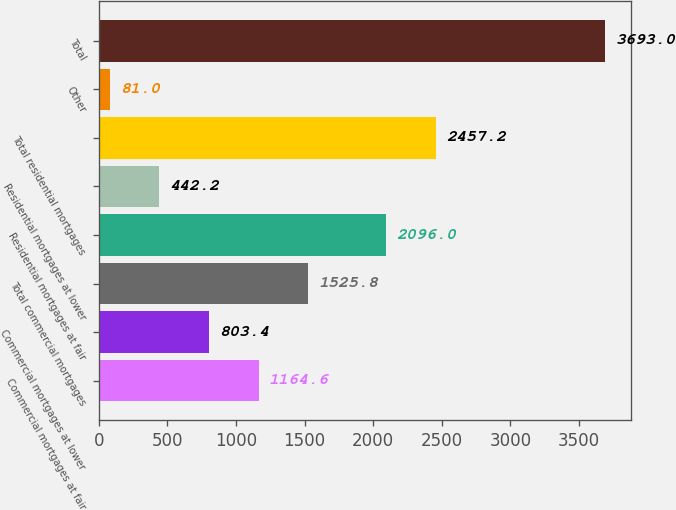Convert chart. <chart><loc_0><loc_0><loc_500><loc_500><bar_chart><fcel>Commercial mortgages at fair<fcel>Commercial mortgages at lower<fcel>Total commercial mortgages<fcel>Residential mortgages at fair<fcel>Residential mortgages at lower<fcel>Total residential mortgages<fcel>Other<fcel>Total<nl><fcel>1164.6<fcel>803.4<fcel>1525.8<fcel>2096<fcel>442.2<fcel>2457.2<fcel>81<fcel>3693<nl></chart> 